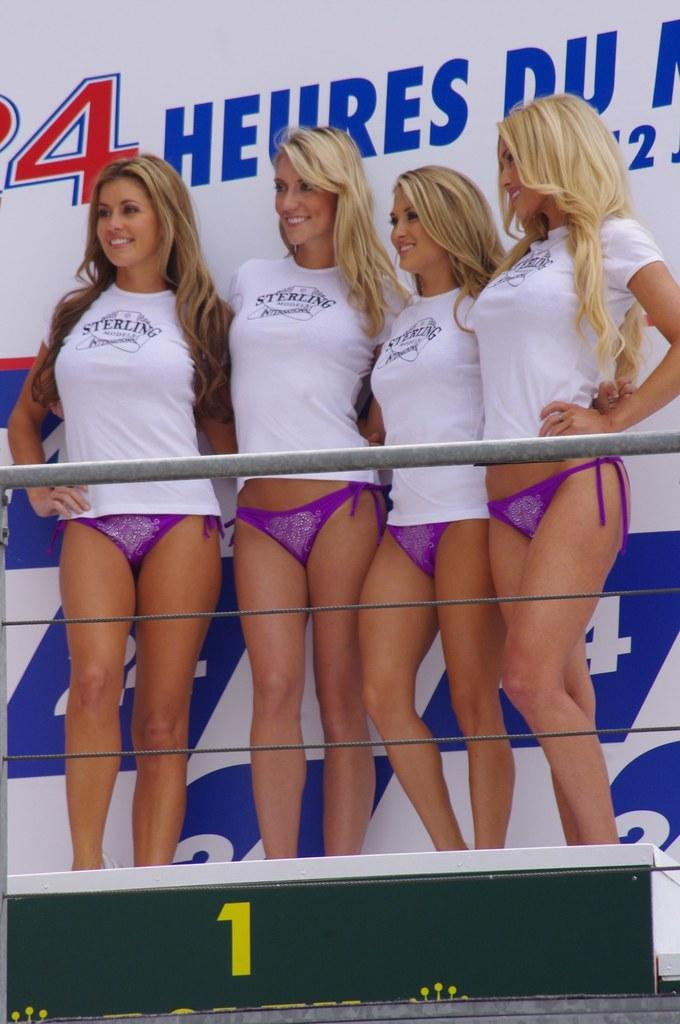How many women are in the image? There are four women in the image. What are the women doing in the image? The women are standing and smiling. What is in front of the women? There is a fence and some objects in front of the women. What can be seen in the background of the image? There is a banner in the background of the image. What type of cart is being used to perform a trick in the image? There is no cart or trick present in the image; it features four women standing and smiling with a fence and objects in front of them, and a banner in the background. 